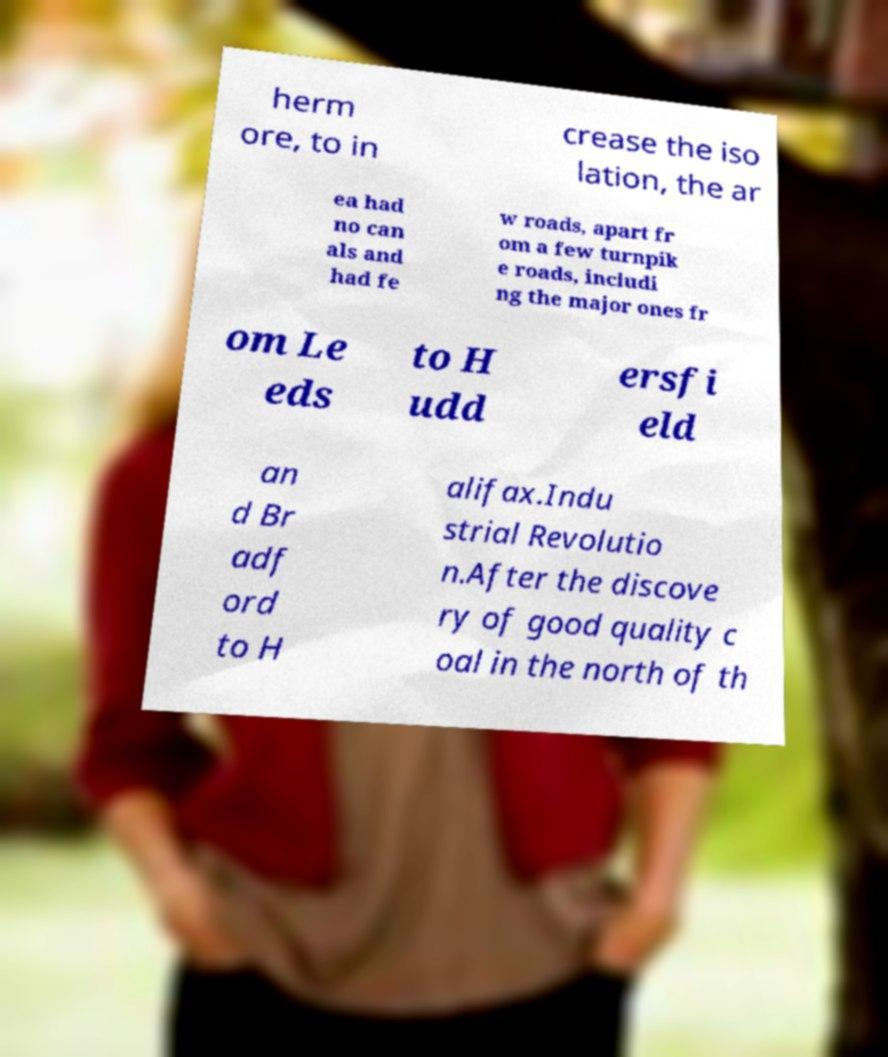For documentation purposes, I need the text within this image transcribed. Could you provide that? herm ore, to in crease the iso lation, the ar ea had no can als and had fe w roads, apart fr om a few turnpik e roads, includi ng the major ones fr om Le eds to H udd ersfi eld an d Br adf ord to H alifax.Indu strial Revolutio n.After the discove ry of good quality c oal in the north of th 